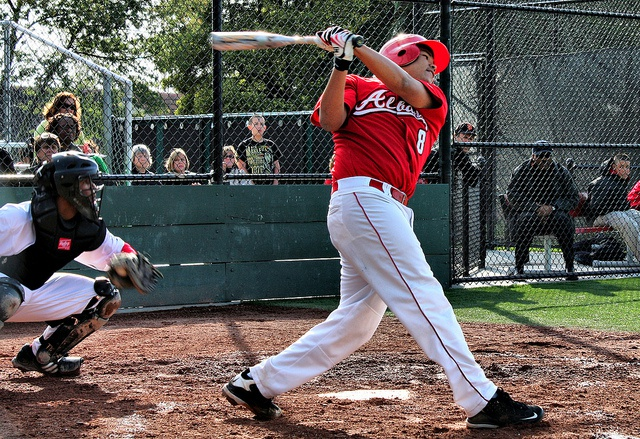Describe the objects in this image and their specific colors. I can see people in lightgray, darkgray, black, and lavender tones, people in lightgray, black, lavender, gray, and darkgray tones, people in lightgray, black, gray, purple, and darkgray tones, people in lightgray, black, gray, and darkgray tones, and people in lightgray, black, gray, and darkgray tones in this image. 